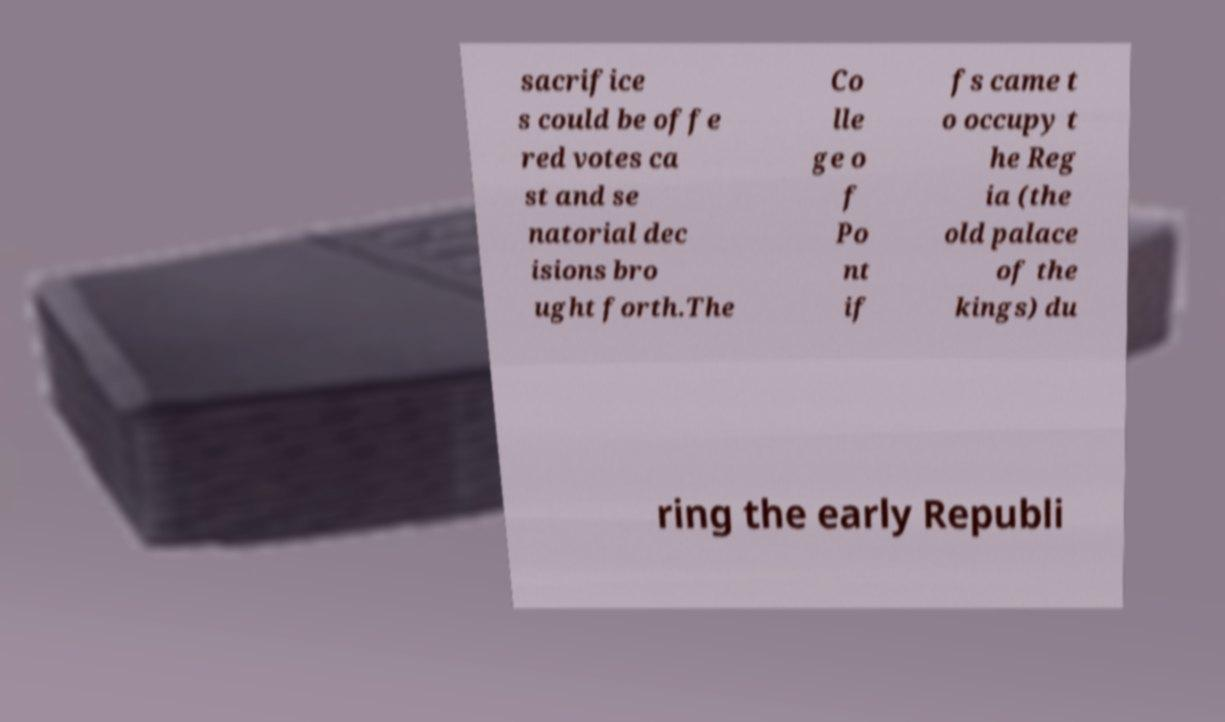What messages or text are displayed in this image? I need them in a readable, typed format. sacrifice s could be offe red votes ca st and se natorial dec isions bro ught forth.The Co lle ge o f Po nt if fs came t o occupy t he Reg ia (the old palace of the kings) du ring the early Republi 